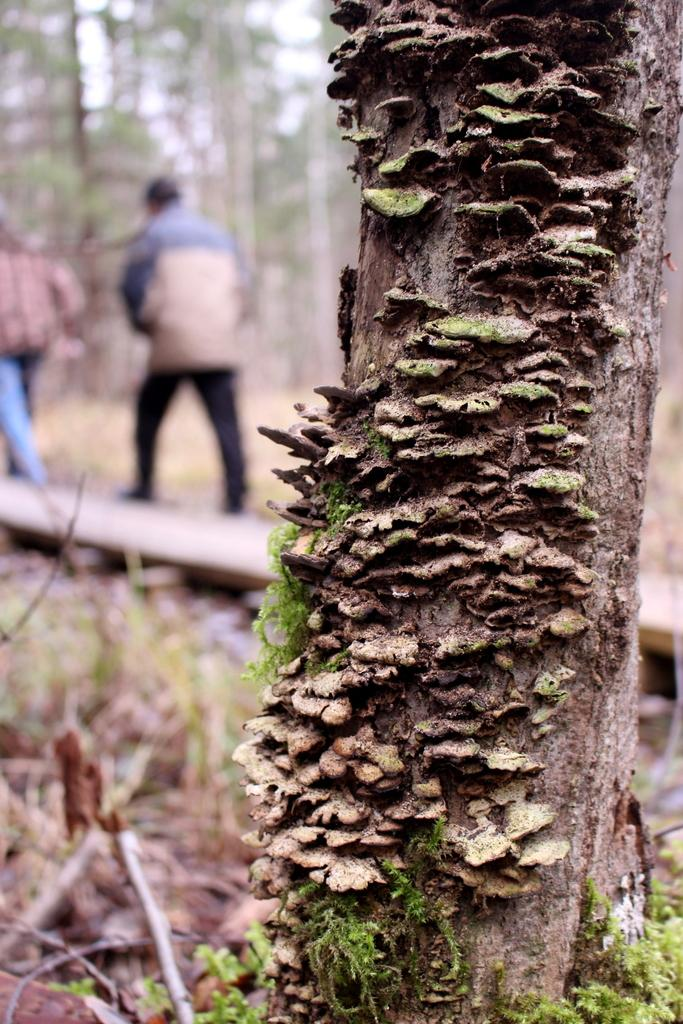What type of plant can be seen in the image? There is a tree with moss in the image. Can you describe the people in the background of the image? There are two persons in the background of the image. What else can be seen in the background of the image? There is a group of trees in the background of the image. What type of fish can be seen swimming in the image? There are no fish present in the image; it features a tree with moss and people in the background. What fact can be learned about the writer from the image? There is no writer or any information about a writer in the image. 